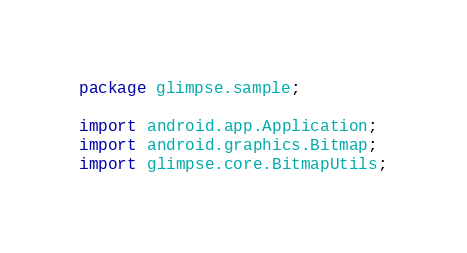Convert code to text. <code><loc_0><loc_0><loc_500><loc_500><_Java_>package glimpse.sample;

import android.app.Application;
import android.graphics.Bitmap;
import glimpse.core.BitmapUtils;</code> 